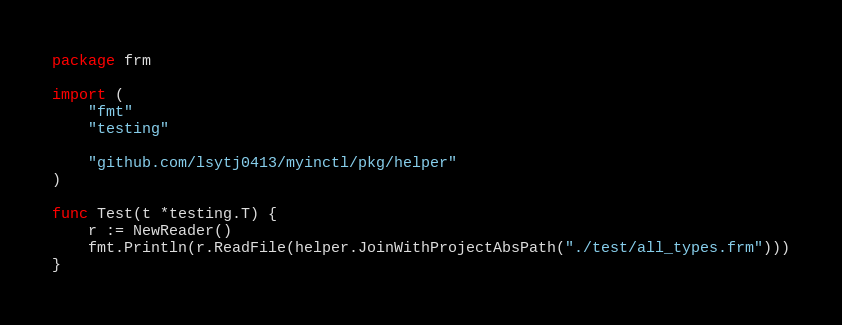<code> <loc_0><loc_0><loc_500><loc_500><_Go_>package frm

import (
	"fmt"
	"testing"

	"github.com/lsytj0413/myinctl/pkg/helper"
)

func Test(t *testing.T) {
	r := NewReader()
	fmt.Println(r.ReadFile(helper.JoinWithProjectAbsPath("./test/all_types.frm")))
}
</code> 